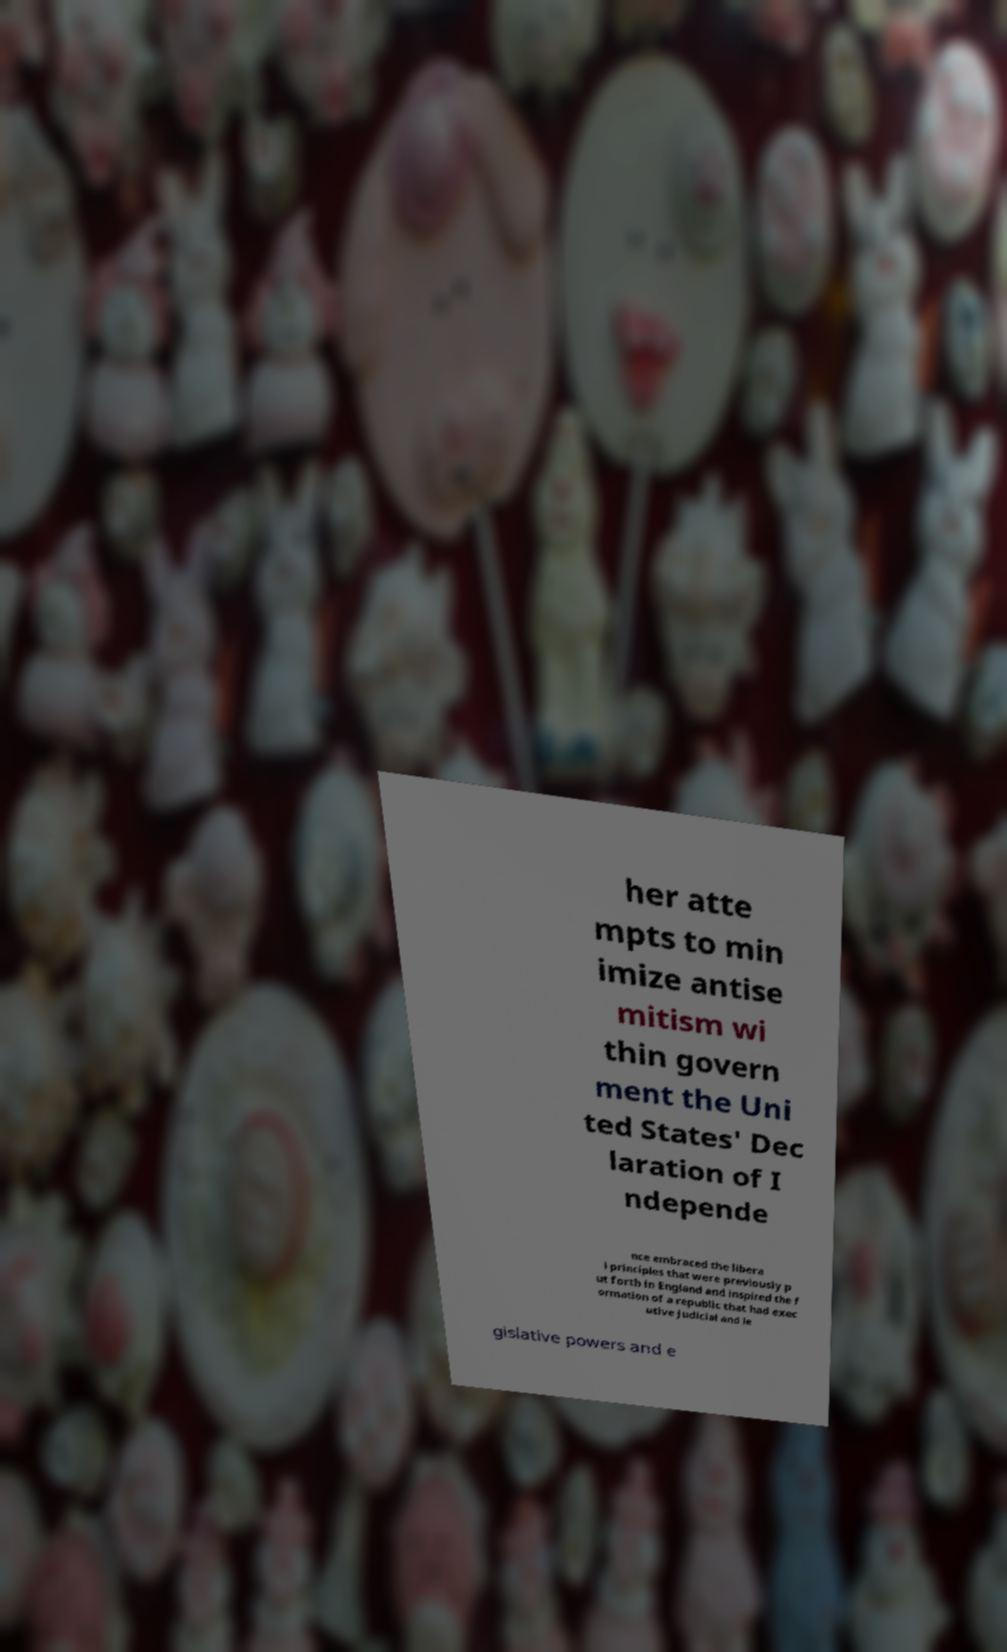Could you assist in decoding the text presented in this image and type it out clearly? her atte mpts to min imize antise mitism wi thin govern ment the Uni ted States' Dec laration of I ndepende nce embraced the libera l principles that were previously p ut forth in England and inspired the f ormation of a republic that had exec utive judicial and le gislative powers and e 